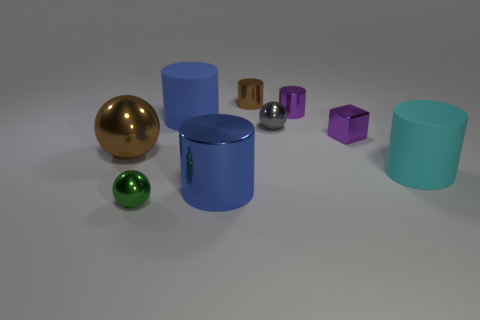There is another cylinder that is the same size as the brown shiny cylinder; what is it made of?
Your response must be concise. Metal. Does the metal block have the same color as the small metal sphere behind the green object?
Provide a short and direct response. No. Is the number of brown metallic things right of the tiny green metallic object less than the number of small purple metallic cylinders?
Provide a short and direct response. No. What number of large gray metallic cylinders are there?
Make the answer very short. 0. What shape is the small thing that is in front of the brown sphere left of the small green shiny object?
Provide a succinct answer. Sphere. There is a large cyan object; what number of metallic cubes are to the right of it?
Your answer should be very brief. 0. Is the material of the big brown thing the same as the blue object in front of the big blue rubber cylinder?
Your answer should be very brief. Yes. Are there any blue rubber cylinders of the same size as the cyan thing?
Provide a succinct answer. Yes. Are there an equal number of big brown objects that are in front of the green metal thing and big brown rubber spheres?
Give a very brief answer. Yes. The cyan matte cylinder is what size?
Give a very brief answer. Large. 